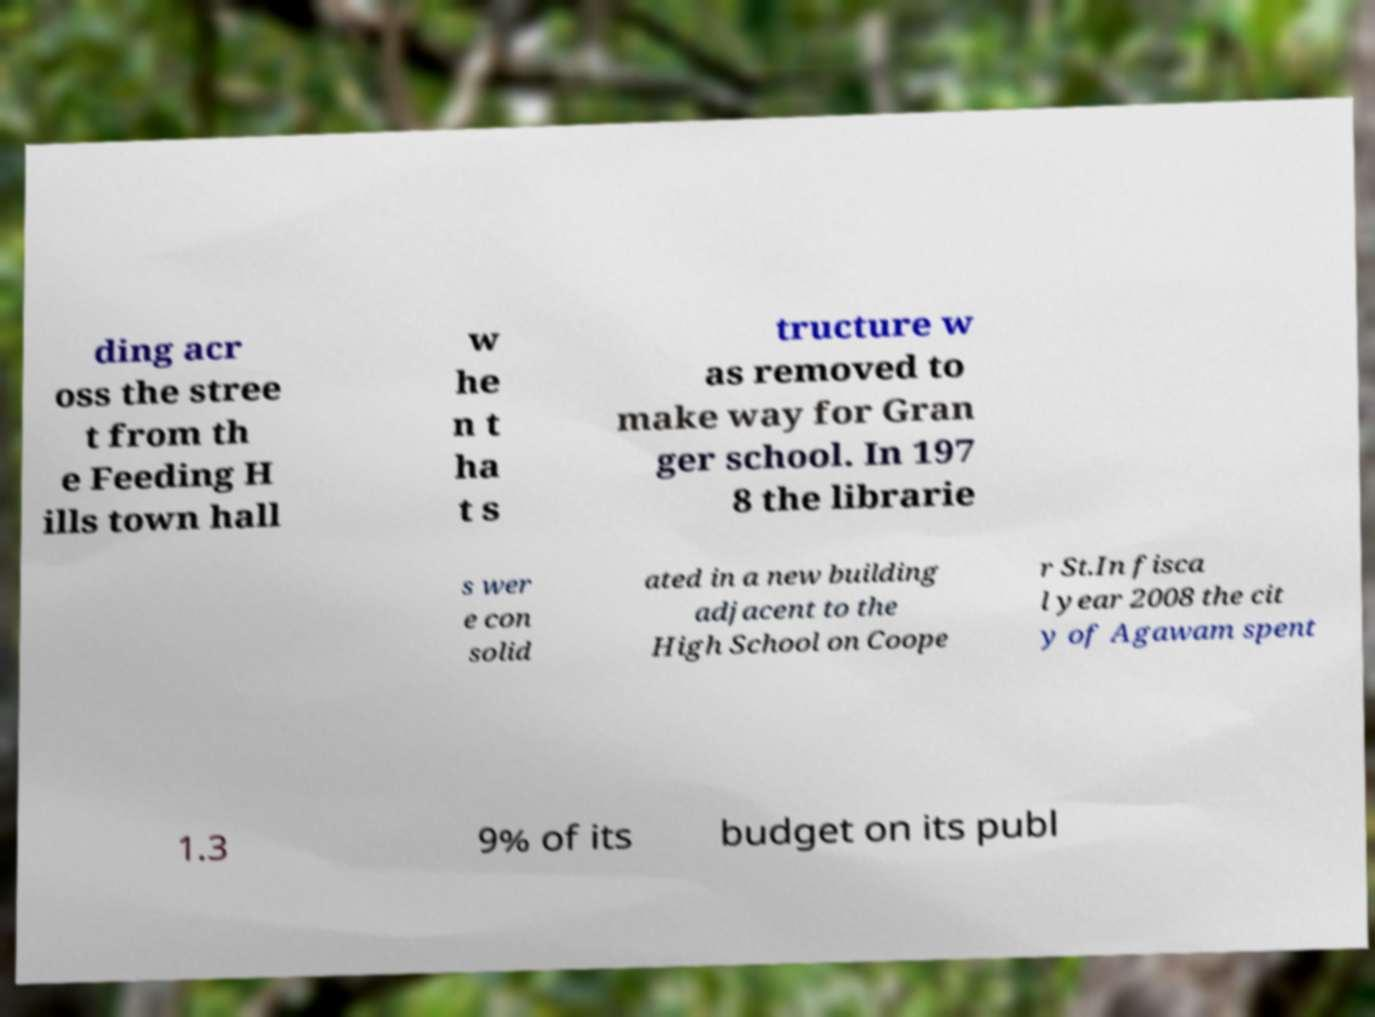Please read and relay the text visible in this image. What does it say? ding acr oss the stree t from th e Feeding H ills town hall w he n t ha t s tructure w as removed to make way for Gran ger school. In 197 8 the librarie s wer e con solid ated in a new building adjacent to the High School on Coope r St.In fisca l year 2008 the cit y of Agawam spent 1.3 9% of its budget on its publ 